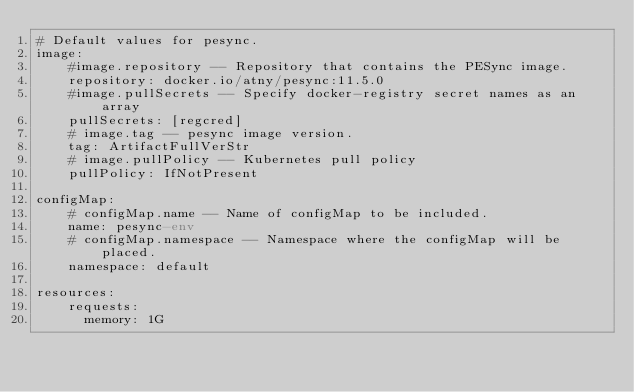Convert code to text. <code><loc_0><loc_0><loc_500><loc_500><_YAML_># Default values for pesync.
image:
    #image.repository -- Repository that contains the PESync image.
    repository: docker.io/atny/pesync:11.5.0
    #image.pullSecrets -- Specify docker-registry secret names as an array
    pullSecrets: [regcred]
    # image.tag -- pesync image version.
    tag: ArtifactFullVerStr
    # image.pullPolicy -- Kubernetes pull policy
    pullPolicy: IfNotPresent

configMap:
    # configMap.name -- Name of configMap to be included.
    name: pesync-env
    # configMap.namespace -- Namespace where the configMap will be placed.
    namespace: default

resources:
    requests:
      memory: 1G</code> 